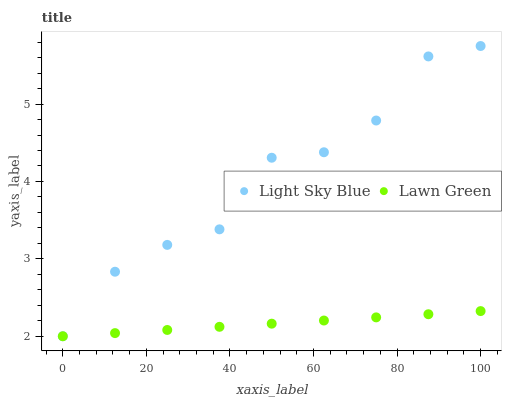Does Lawn Green have the minimum area under the curve?
Answer yes or no. Yes. Does Light Sky Blue have the maximum area under the curve?
Answer yes or no. Yes. Does Light Sky Blue have the minimum area under the curve?
Answer yes or no. No. Is Lawn Green the smoothest?
Answer yes or no. Yes. Is Light Sky Blue the roughest?
Answer yes or no. Yes. Is Light Sky Blue the smoothest?
Answer yes or no. No. Does Lawn Green have the lowest value?
Answer yes or no. Yes. Does Light Sky Blue have the highest value?
Answer yes or no. Yes. Does Light Sky Blue intersect Lawn Green?
Answer yes or no. Yes. Is Light Sky Blue less than Lawn Green?
Answer yes or no. No. Is Light Sky Blue greater than Lawn Green?
Answer yes or no. No. 